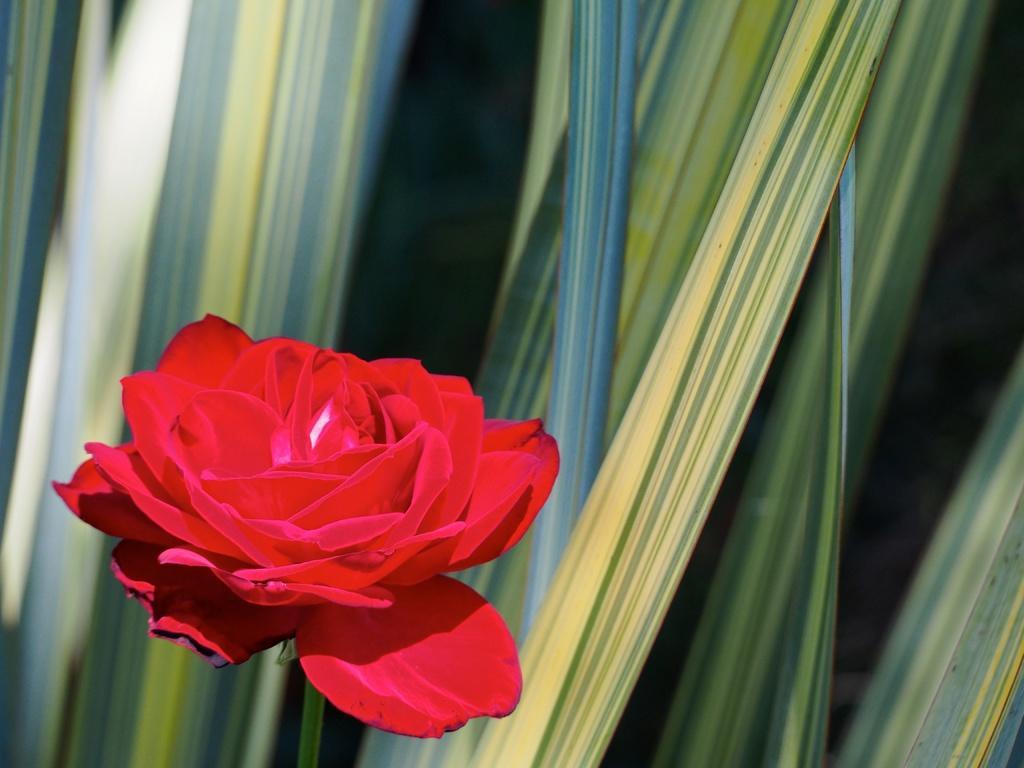Can you describe this image briefly? In this picture I can see the flower plant. 